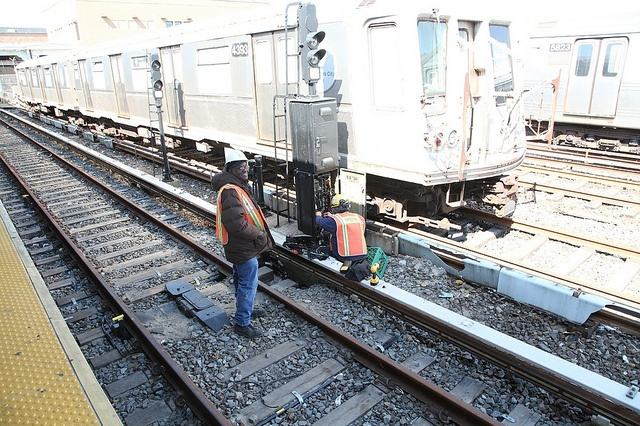Describe the objects in this image and their specific colors. I can see train in white, darkgray, black, and gray tones, train in white, black, gray, and darkgray tones, people in white, black, gray, and navy tones, people in white, salmon, beige, black, and navy tones, and traffic light in white, lightgray, and darkgray tones in this image. 